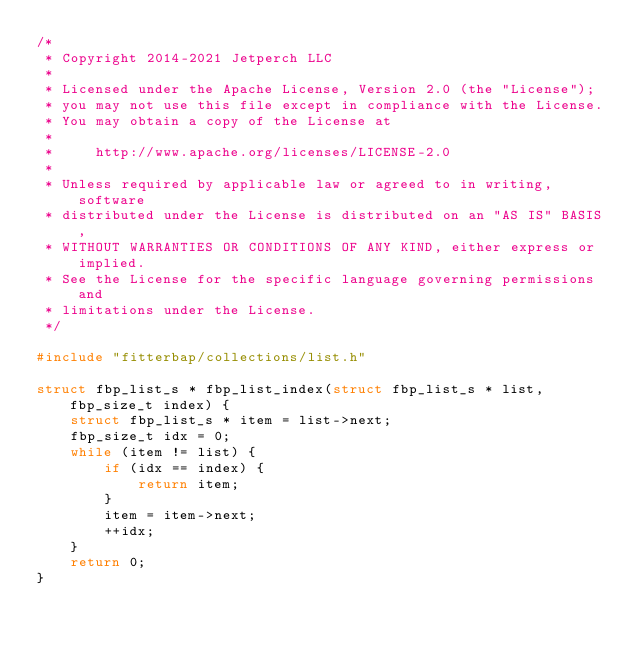Convert code to text. <code><loc_0><loc_0><loc_500><loc_500><_C_>/*
 * Copyright 2014-2021 Jetperch LLC
 *
 * Licensed under the Apache License, Version 2.0 (the "License");
 * you may not use this file except in compliance with the License.
 * You may obtain a copy of the License at
 *
 *     http://www.apache.org/licenses/LICENSE-2.0
 *
 * Unless required by applicable law or agreed to in writing, software
 * distributed under the License is distributed on an "AS IS" BASIS,
 * WITHOUT WARRANTIES OR CONDITIONS OF ANY KIND, either express or implied.
 * See the License for the specific language governing permissions and
 * limitations under the License.
 */

#include "fitterbap/collections/list.h"

struct fbp_list_s * fbp_list_index(struct fbp_list_s * list, fbp_size_t index) {
    struct fbp_list_s * item = list->next;
    fbp_size_t idx = 0;
    while (item != list) {
        if (idx == index) {
            return item;
        }
        item = item->next;
        ++idx;
    }
    return 0;
}
</code> 